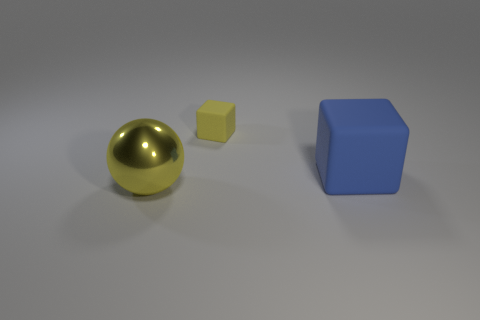Is there anything else that is made of the same material as the large yellow thing?
Provide a short and direct response. No. Are any tiny red blocks visible?
Provide a short and direct response. No. Is the number of big blue matte objects that are to the left of the large blue block greater than the number of blue blocks that are to the left of the small rubber object?
Your answer should be very brief. No. What material is the thing that is in front of the yellow matte cube and to the left of the big matte cube?
Your answer should be compact. Metal. Is the shape of the blue rubber thing the same as the yellow matte thing?
Your answer should be very brief. Yes. Is there any other thing that has the same size as the yellow cube?
Provide a short and direct response. No. There is a large rubber cube; what number of yellow objects are behind it?
Keep it short and to the point. 1. Do the yellow thing on the right side of the metal sphere and the blue object have the same size?
Your answer should be very brief. No. The tiny rubber object that is the same shape as the big blue matte object is what color?
Make the answer very short. Yellow. Is there any other thing that is the same shape as the yellow metallic thing?
Ensure brevity in your answer.  No. 